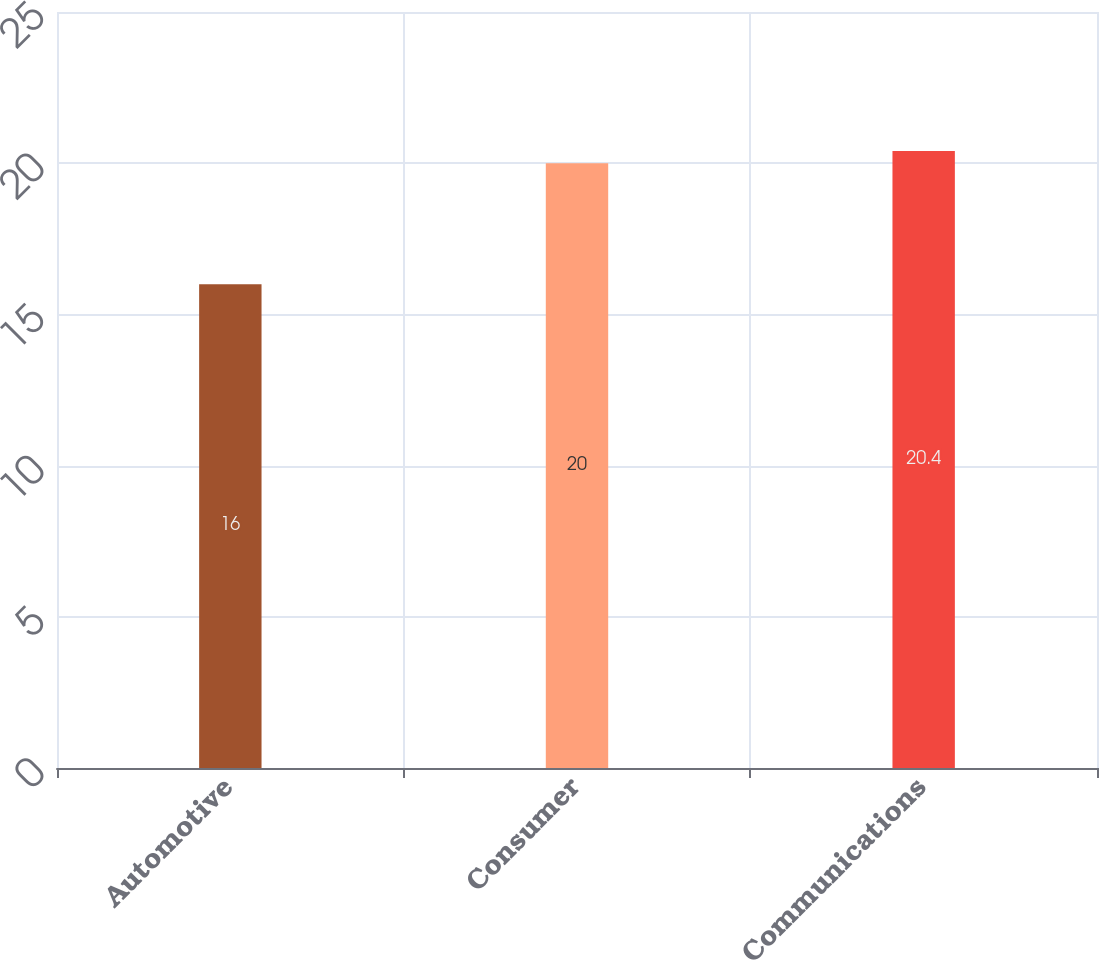Convert chart to OTSL. <chart><loc_0><loc_0><loc_500><loc_500><bar_chart><fcel>Automotive<fcel>Consumer<fcel>Communications<nl><fcel>16<fcel>20<fcel>20.4<nl></chart> 